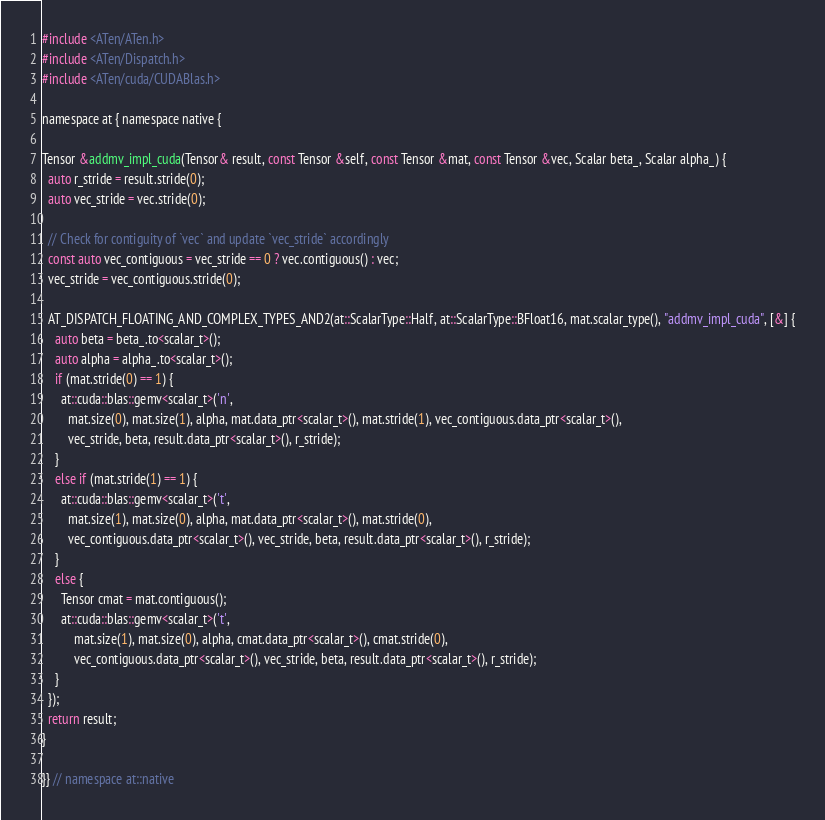<code> <loc_0><loc_0><loc_500><loc_500><_Cuda_>#include <ATen/ATen.h>
#include <ATen/Dispatch.h>
#include <ATen/cuda/CUDABlas.h>

namespace at { namespace native {

Tensor &addmv_impl_cuda(Tensor& result, const Tensor &self, const Tensor &mat, const Tensor &vec, Scalar beta_, Scalar alpha_) {
  auto r_stride = result.stride(0);
  auto vec_stride = vec.stride(0);

  // Check for contiguity of `vec` and update `vec_stride` accordingly
  const auto vec_contiguous = vec_stride == 0 ? vec.contiguous() : vec;
  vec_stride = vec_contiguous.stride(0);

  AT_DISPATCH_FLOATING_AND_COMPLEX_TYPES_AND2(at::ScalarType::Half, at::ScalarType::BFloat16, mat.scalar_type(), "addmv_impl_cuda", [&] {
    auto beta = beta_.to<scalar_t>();
    auto alpha = alpha_.to<scalar_t>();
    if (mat.stride(0) == 1) {
      at::cuda::blas::gemv<scalar_t>('n',
        mat.size(0), mat.size(1), alpha, mat.data_ptr<scalar_t>(), mat.stride(1), vec_contiguous.data_ptr<scalar_t>(),
        vec_stride, beta, result.data_ptr<scalar_t>(), r_stride);
    }
    else if (mat.stride(1) == 1) {
      at::cuda::blas::gemv<scalar_t>('t',
        mat.size(1), mat.size(0), alpha, mat.data_ptr<scalar_t>(), mat.stride(0),
        vec_contiguous.data_ptr<scalar_t>(), vec_stride, beta, result.data_ptr<scalar_t>(), r_stride);
    }
    else {
      Tensor cmat = mat.contiguous();
      at::cuda::blas::gemv<scalar_t>('t',
          mat.size(1), mat.size(0), alpha, cmat.data_ptr<scalar_t>(), cmat.stride(0),
          vec_contiguous.data_ptr<scalar_t>(), vec_stride, beta, result.data_ptr<scalar_t>(), r_stride);
    }
  });
  return result;
}

}} // namespace at::native
</code> 